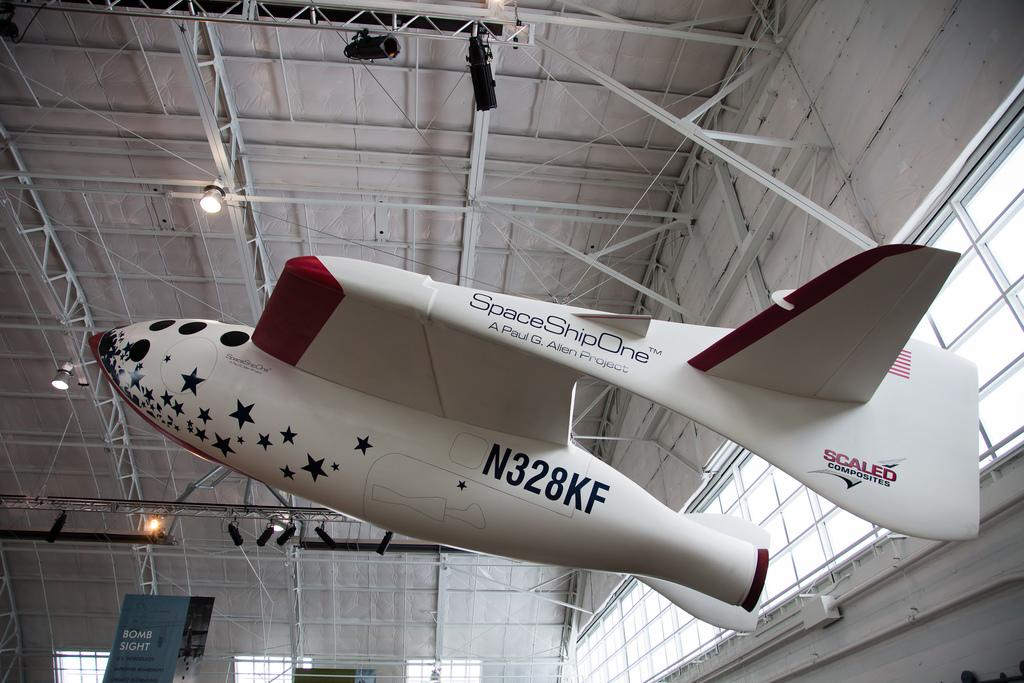<image>
Provide a brief description of the given image. a Space Ship One hanging from the rafters of a hangar 